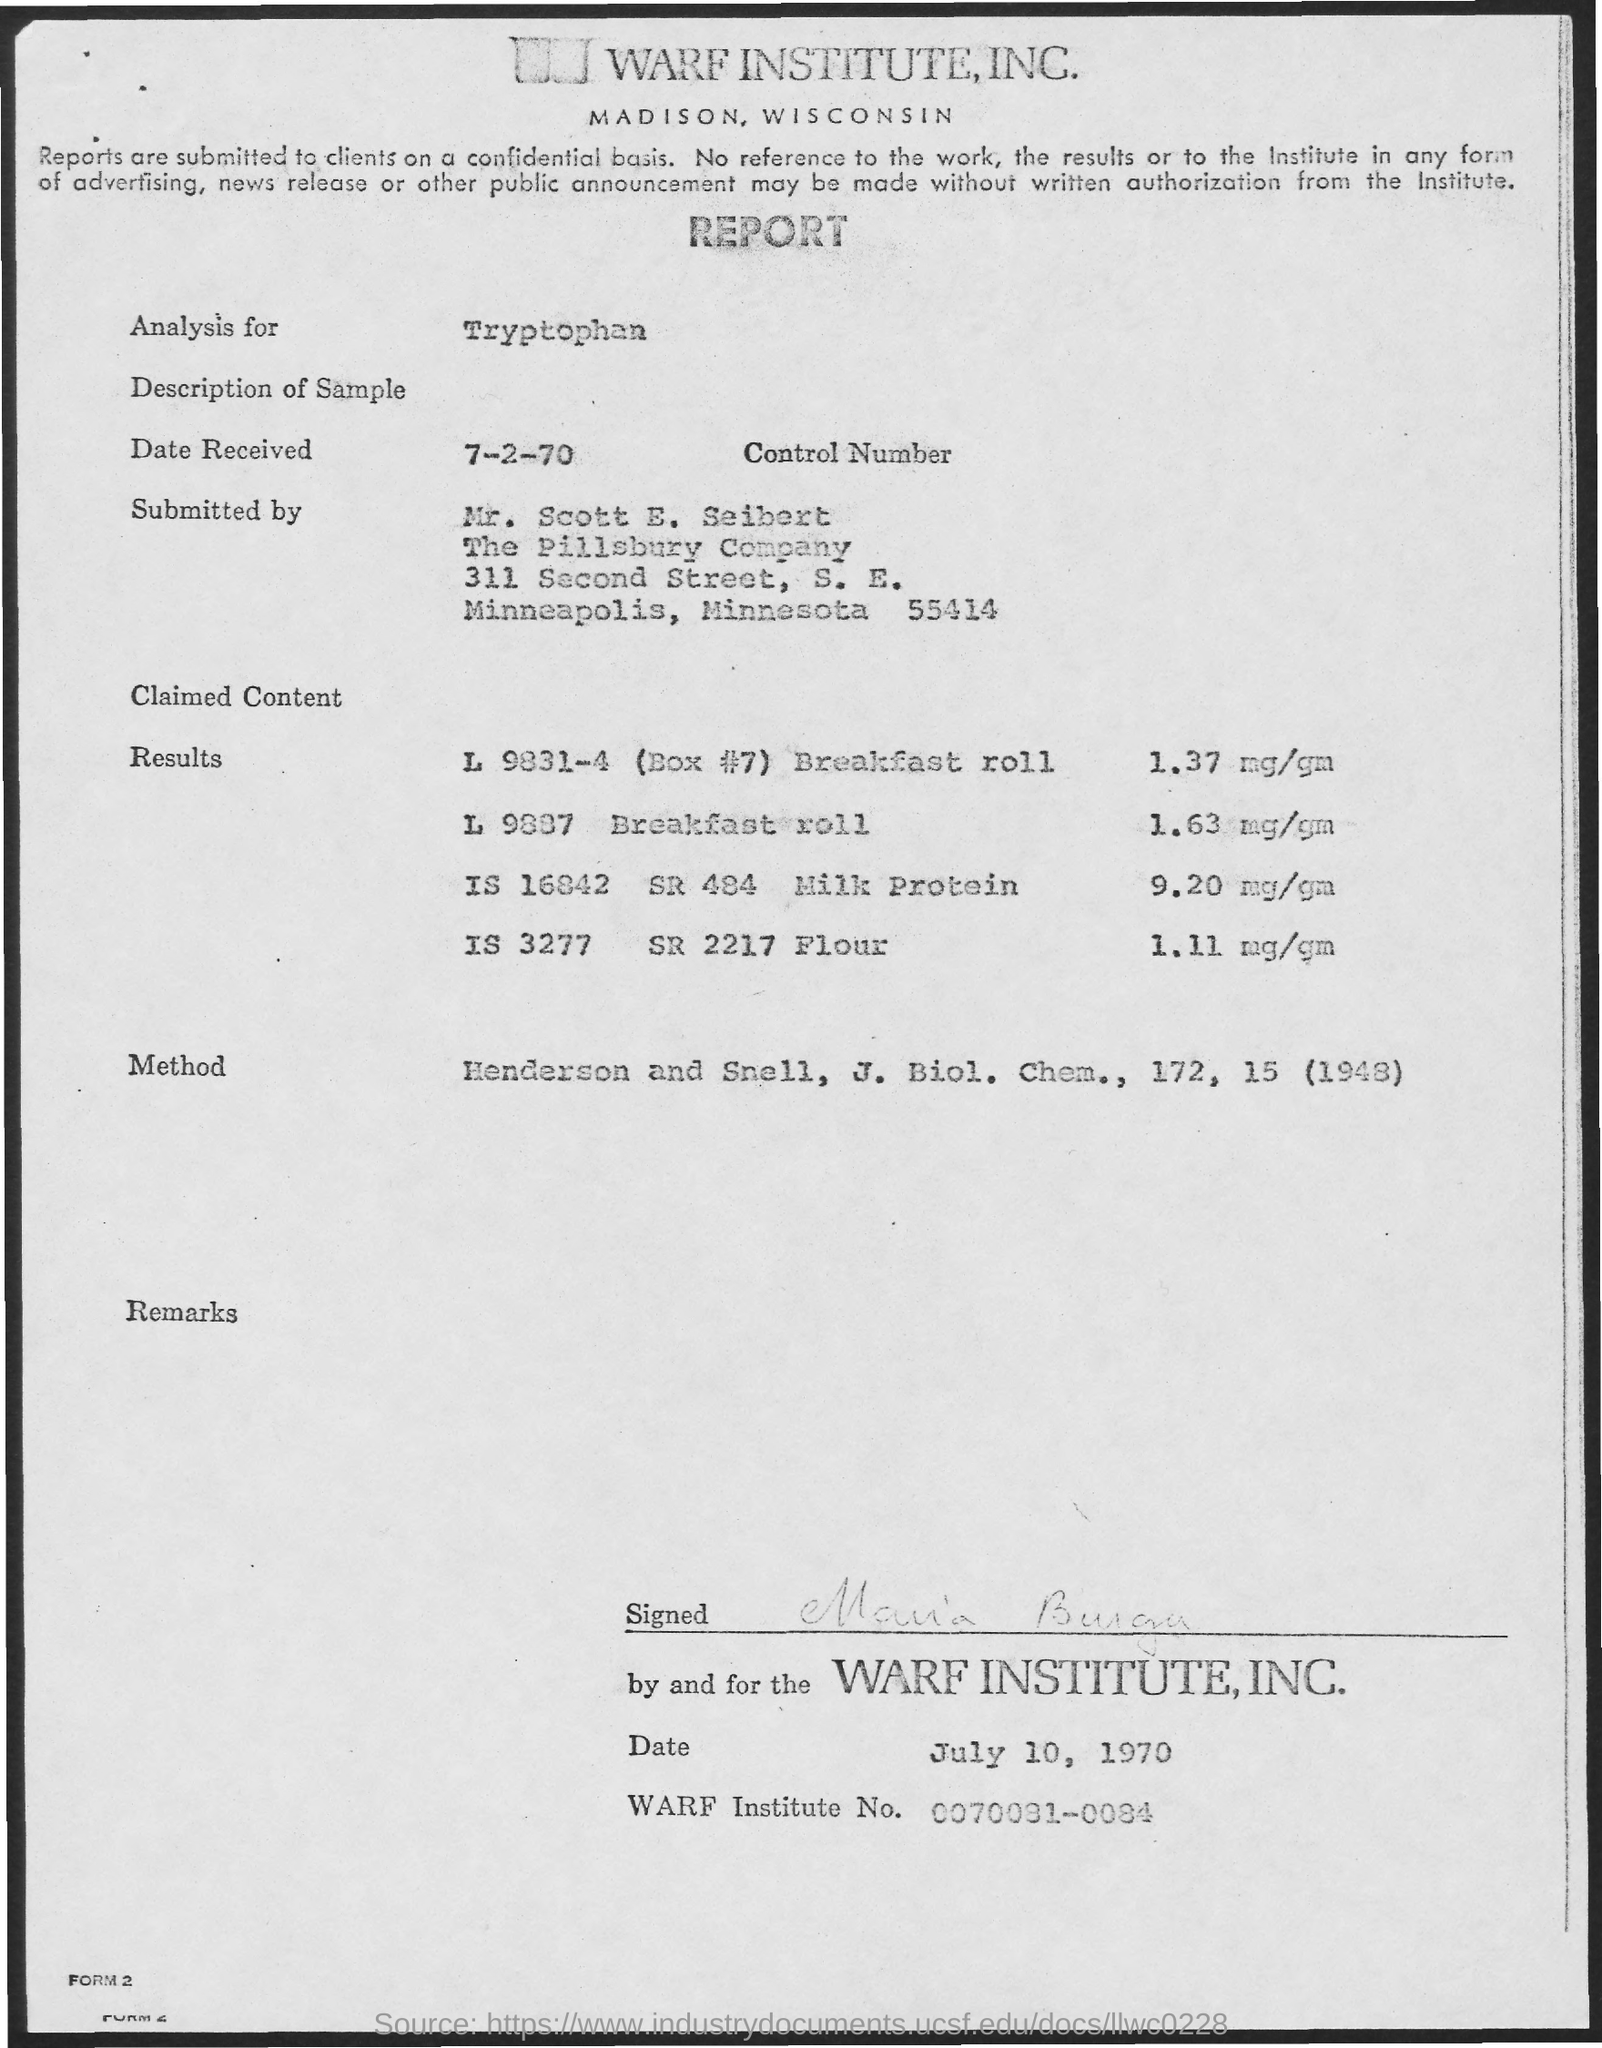List a handful of essential elements in this visual. The purpose of the analysis is to determine the content of tryptophan in the sample. The Treaty on the Non-Proliferation of Nuclear Weapons was signed on July 10, 1970. The document is signed by Maria Burga. On July 2, 1970, the date received was 7-2-70. 